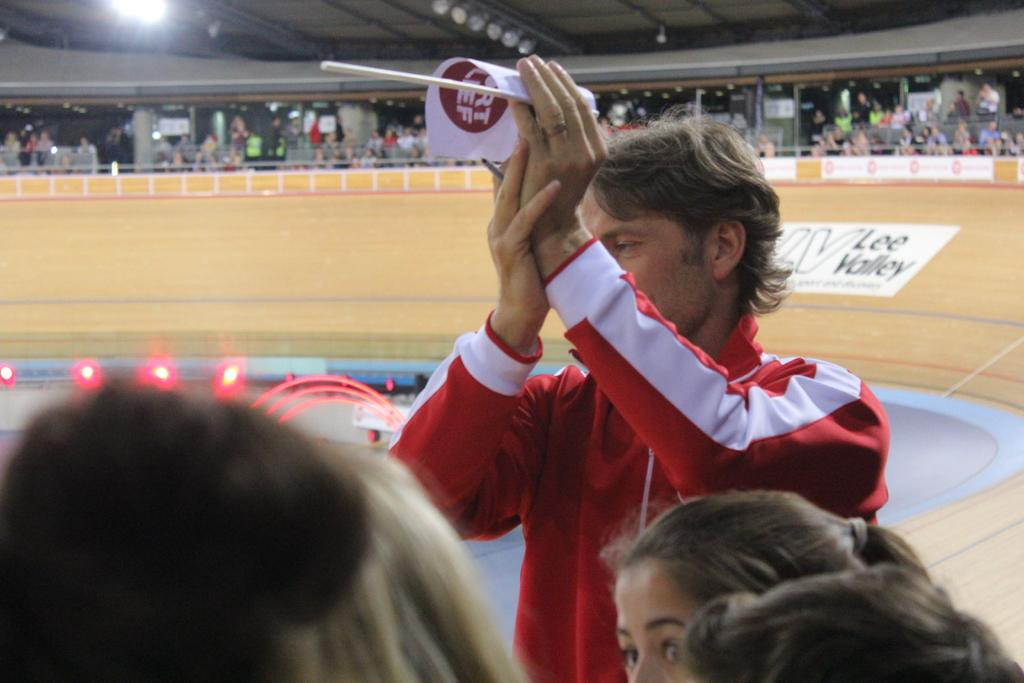What is the man in the image holding? The man is holding a paper and a pen in the image. What might the man be doing with the paper and pen? The man might be writing or taking notes with the pen and paper. How many people can be seen in the image? There are people visible in the image. What can be seen in the background of the image? In the background of the image, there is a wall, lights, a ceiling, and benches. How many deer can be seen in the image? There are no deer present in the image. What type of company is the man working for in the image? The image does not provide any information about the company the man might be working for. 